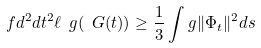Convert formula to latex. <formula><loc_0><loc_0><loc_500><loc_500>\ f { d ^ { 2 } } { d t ^ { 2 } } \ell _ { \ } g ( \ G ( t ) ) \geq \frac { 1 } { 3 } \int _ { \ } g \| \Phi _ { t } \| ^ { 2 } d s</formula> 